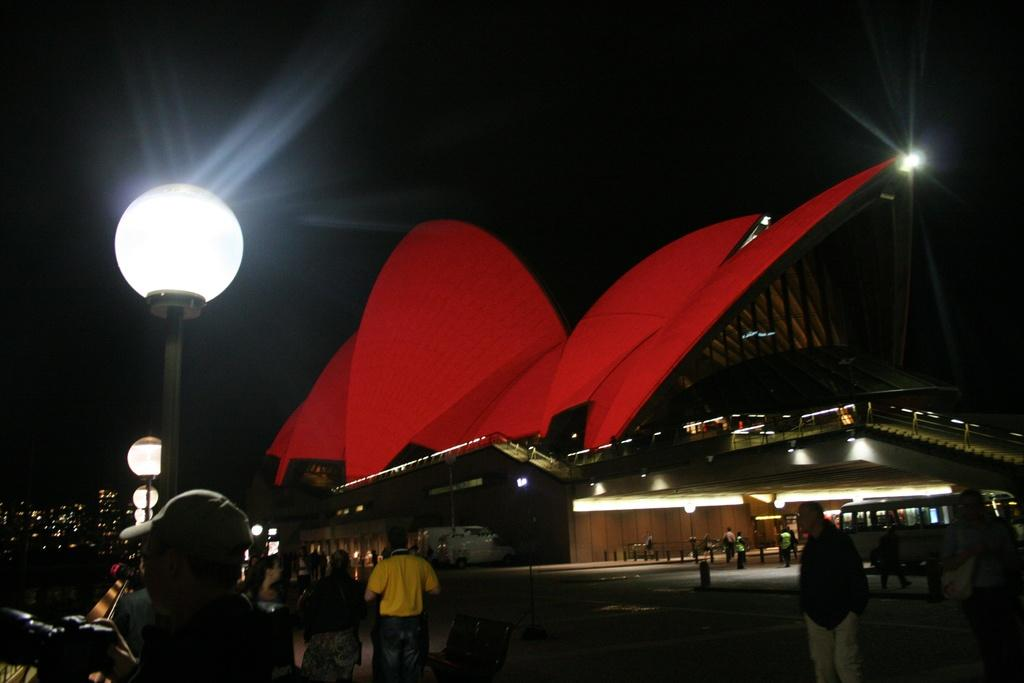What can be seen in the foreground of the image? In the foreground, there is a crowd on the road, light poles, a fence, vehicles, buildings, and the rooftop of a building. What is the condition of the sky in the image? The sky is visible in the background, but there is no indication that it is nighttime in the image. Additionally, there are no stones, badges, or pipes present in the image. What type of pipe is being used by the crowd in the image? There are no pipes present in the image. The crowd is on the road, and there are light poles, a fence, vehicles, buildings, and the rooftop of a building visible in the foreground. 